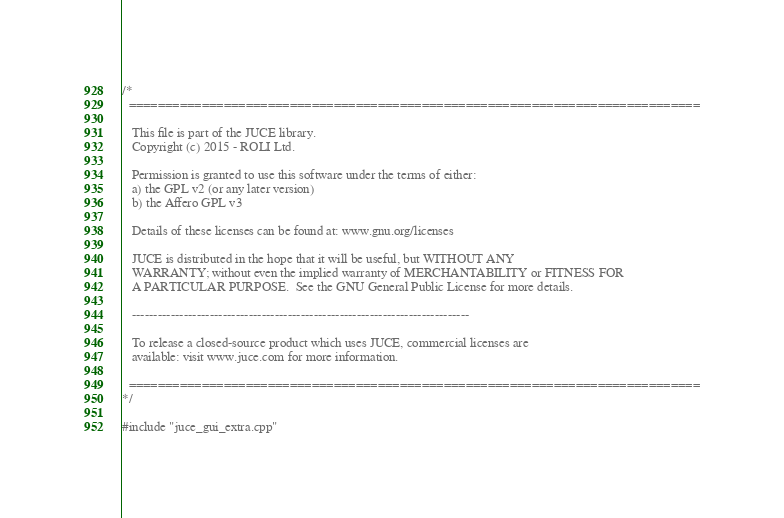<code> <loc_0><loc_0><loc_500><loc_500><_ObjectiveC_>/*
  ==============================================================================

   This file is part of the JUCE library.
   Copyright (c) 2015 - ROLI Ltd.

   Permission is granted to use this software under the terms of either:
   a) the GPL v2 (or any later version)
   b) the Affero GPL v3

   Details of these licenses can be found at: www.gnu.org/licenses

   JUCE is distributed in the hope that it will be useful, but WITHOUT ANY
   WARRANTY; without even the implied warranty of MERCHANTABILITY or FITNESS FOR
   A PARTICULAR PURPOSE.  See the GNU General Public License for more details.

   ------------------------------------------------------------------------------

   To release a closed-source product which uses JUCE, commercial licenses are
   available: visit www.juce.com for more information.

  ==============================================================================
*/

#include "juce_gui_extra.cpp"
</code> 